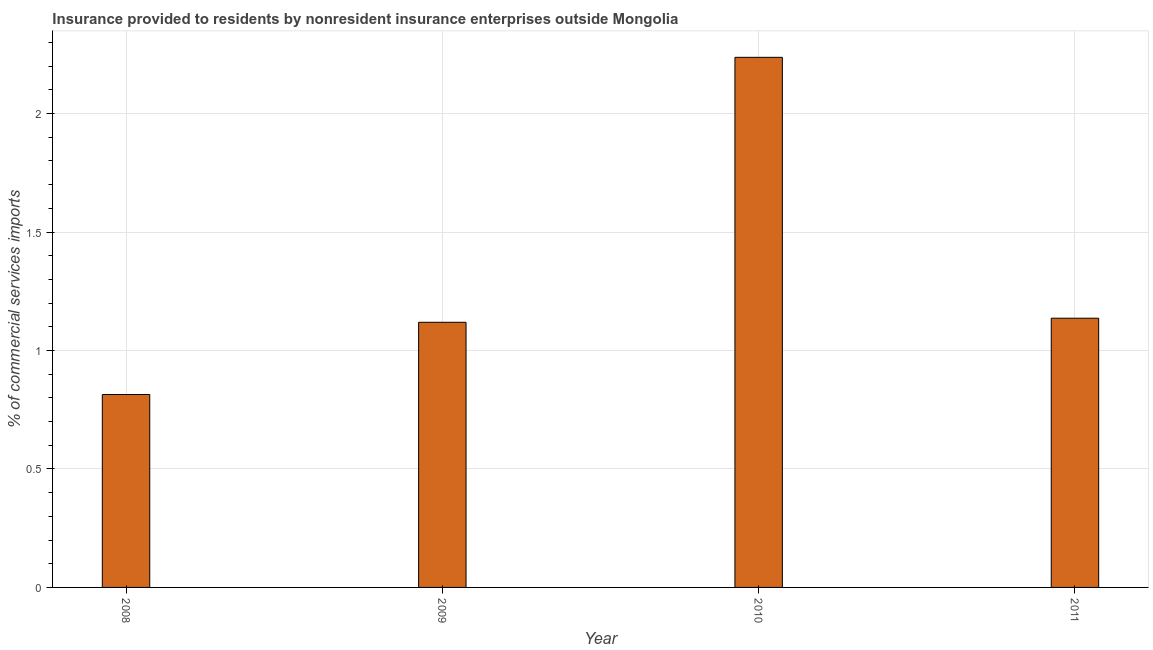Does the graph contain any zero values?
Ensure brevity in your answer.  No. Does the graph contain grids?
Provide a short and direct response. Yes. What is the title of the graph?
Your response must be concise. Insurance provided to residents by nonresident insurance enterprises outside Mongolia. What is the label or title of the Y-axis?
Ensure brevity in your answer.  % of commercial services imports. What is the insurance provided by non-residents in 2011?
Offer a very short reply. 1.14. Across all years, what is the maximum insurance provided by non-residents?
Offer a very short reply. 2.24. Across all years, what is the minimum insurance provided by non-residents?
Offer a very short reply. 0.81. What is the sum of the insurance provided by non-residents?
Give a very brief answer. 5.31. What is the difference between the insurance provided by non-residents in 2009 and 2010?
Your answer should be very brief. -1.12. What is the average insurance provided by non-residents per year?
Give a very brief answer. 1.33. What is the median insurance provided by non-residents?
Give a very brief answer. 1.13. In how many years, is the insurance provided by non-residents greater than 0.6 %?
Your response must be concise. 4. Do a majority of the years between 2008 and 2009 (inclusive) have insurance provided by non-residents greater than 0.4 %?
Ensure brevity in your answer.  Yes. What is the ratio of the insurance provided by non-residents in 2008 to that in 2011?
Ensure brevity in your answer.  0.72. Is the insurance provided by non-residents in 2009 less than that in 2010?
Your answer should be very brief. Yes. Is the difference between the insurance provided by non-residents in 2008 and 2009 greater than the difference between any two years?
Keep it short and to the point. No. What is the difference between the highest and the second highest insurance provided by non-residents?
Provide a short and direct response. 1.1. Is the sum of the insurance provided by non-residents in 2008 and 2010 greater than the maximum insurance provided by non-residents across all years?
Provide a succinct answer. Yes. What is the difference between the highest and the lowest insurance provided by non-residents?
Provide a short and direct response. 1.42. In how many years, is the insurance provided by non-residents greater than the average insurance provided by non-residents taken over all years?
Keep it short and to the point. 1. What is the difference between two consecutive major ticks on the Y-axis?
Ensure brevity in your answer.  0.5. Are the values on the major ticks of Y-axis written in scientific E-notation?
Offer a terse response. No. What is the % of commercial services imports of 2008?
Give a very brief answer. 0.81. What is the % of commercial services imports of 2009?
Your answer should be very brief. 1.12. What is the % of commercial services imports of 2010?
Your answer should be very brief. 2.24. What is the % of commercial services imports in 2011?
Ensure brevity in your answer.  1.14. What is the difference between the % of commercial services imports in 2008 and 2009?
Provide a succinct answer. -0.3. What is the difference between the % of commercial services imports in 2008 and 2010?
Offer a very short reply. -1.42. What is the difference between the % of commercial services imports in 2008 and 2011?
Offer a very short reply. -0.32. What is the difference between the % of commercial services imports in 2009 and 2010?
Your answer should be compact. -1.12. What is the difference between the % of commercial services imports in 2009 and 2011?
Your answer should be very brief. -0.02. What is the difference between the % of commercial services imports in 2010 and 2011?
Ensure brevity in your answer.  1.1. What is the ratio of the % of commercial services imports in 2008 to that in 2009?
Your answer should be compact. 0.73. What is the ratio of the % of commercial services imports in 2008 to that in 2010?
Keep it short and to the point. 0.36. What is the ratio of the % of commercial services imports in 2008 to that in 2011?
Ensure brevity in your answer.  0.72. What is the ratio of the % of commercial services imports in 2010 to that in 2011?
Make the answer very short. 1.97. 